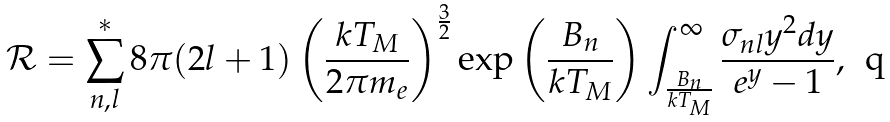<formula> <loc_0><loc_0><loc_500><loc_500>\mathcal { R } = \sum _ { n , l } ^ { * } 8 \pi ( 2 l + 1 ) \left ( \frac { k T _ { M } } { 2 \pi m _ { e } } \right ) ^ { \frac { 3 } { 2 } } \exp \left ( \frac { B _ { n } } { k T _ { M } } \right ) \int _ { \frac { B _ { n } } { k T _ { M } } } ^ { \infty } \frac { \sigma _ { n l } y ^ { 2 } d y } { e ^ { y } - 1 } ,</formula> 